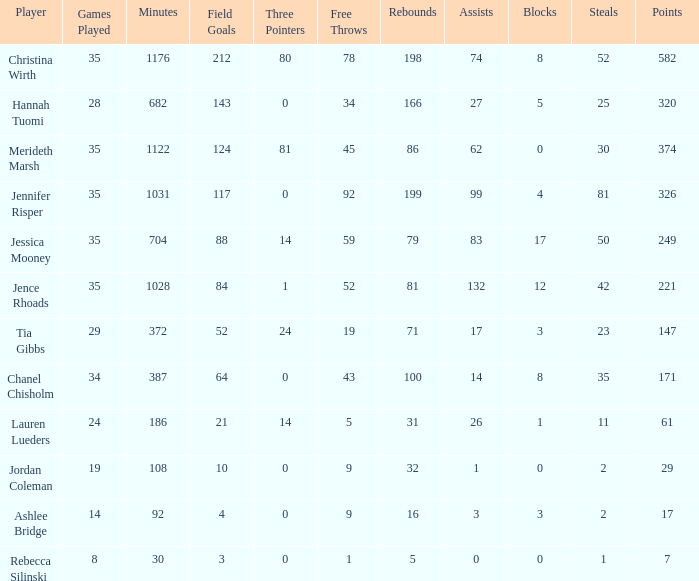What is the minimum number of games played by the player with 50 thefts? 35.0. 